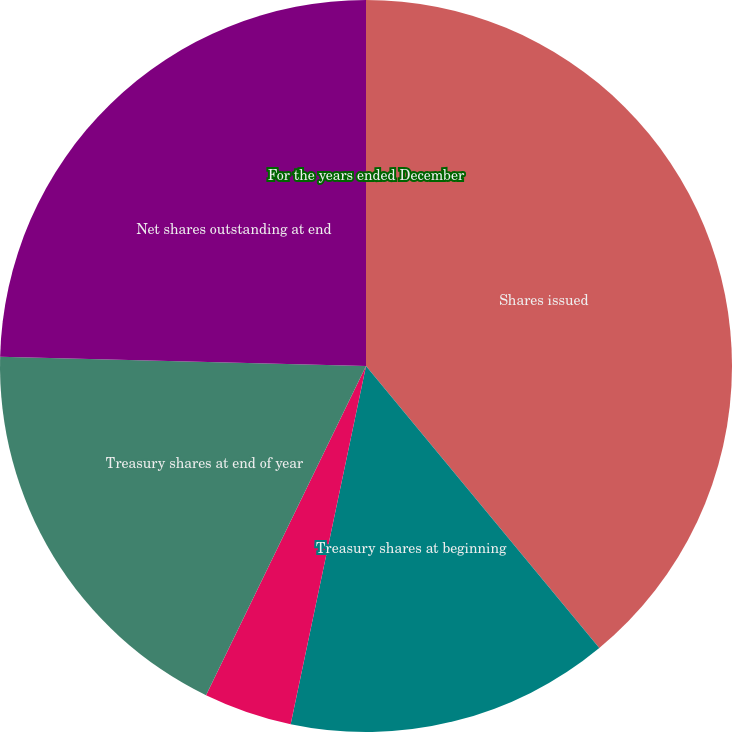<chart> <loc_0><loc_0><loc_500><loc_500><pie_chart><fcel>For the years ended December<fcel>Shares issued<fcel>Treasury shares at beginning<fcel>Stock options and benefits<fcel>Treasury shares at end of year<fcel>Net shares outstanding at end<nl><fcel>0.0%<fcel>39.0%<fcel>14.3%<fcel>3.9%<fcel>18.2%<fcel>24.6%<nl></chart> 